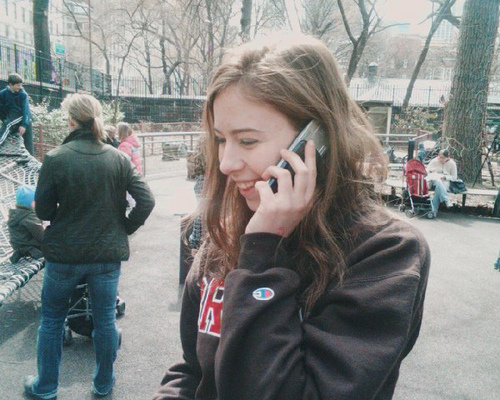Identify the text displayed in this image. R 